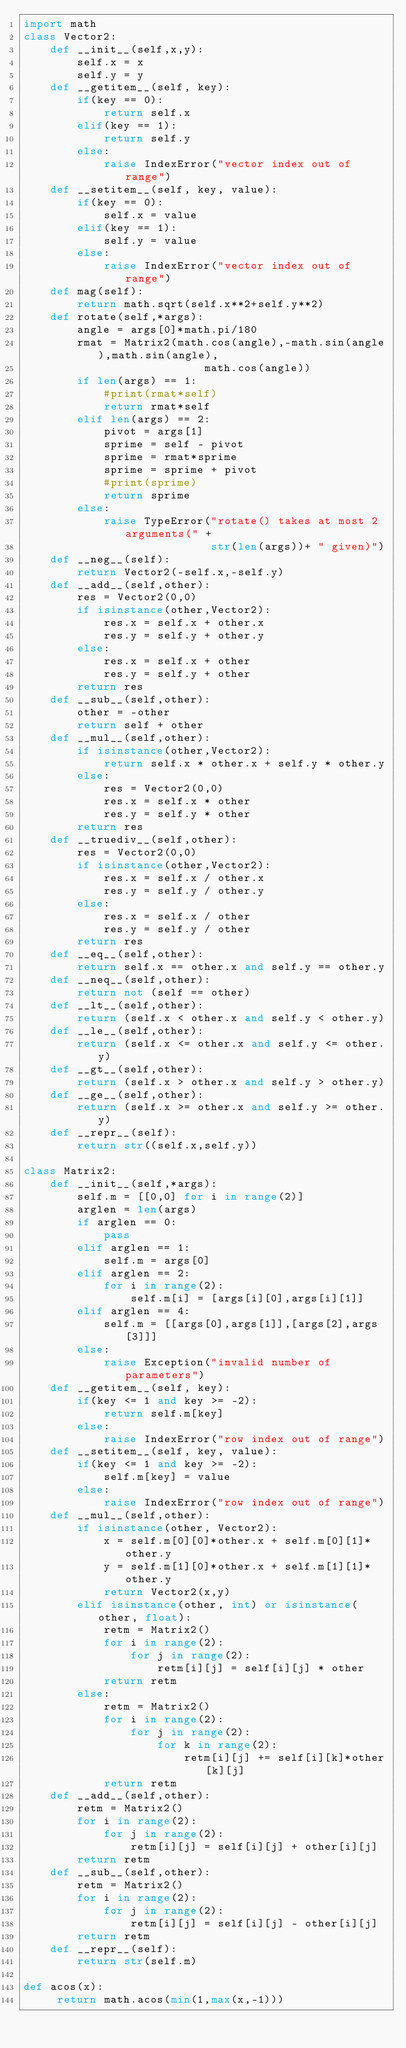Convert code to text. <code><loc_0><loc_0><loc_500><loc_500><_Python_>import math
class Vector2:
    def __init__(self,x,y):
        self.x = x
        self.y = y
    def __getitem__(self, key):
        if(key == 0):
            return self.x
        elif(key == 1):
            return self.y
        else:
            raise IndexError("vector index out of range")
    def __setitem__(self, key, value):
        if(key == 0):
            self.x = value
        elif(key == 1):
            self.y = value
        else:
            raise IndexError("vector index out of range")
    def mag(self):
        return math.sqrt(self.x**2+self.y**2)
    def rotate(self,*args):
        angle = args[0]*math.pi/180
        rmat = Matrix2(math.cos(angle),-math.sin(angle),math.sin(angle),
                           math.cos(angle))
        if len(args) == 1:
            #print(rmat*self)
            return rmat*self
        elif len(args) == 2:
            pivot = args[1]
            sprime = self - pivot
            sprime = rmat*sprime
            sprime = sprime + pivot
            #print(sprime)
            return sprime
        else:
            raise TypeError("rotate() takes at most 2 arguments(" +
                            str(len(args))+ " given)")
    def __neg__(self):
        return Vector2(-self.x,-self.y)
    def __add__(self,other):
        res = Vector2(0,0)
        if isinstance(other,Vector2):
            res.x = self.x + other.x
            res.y = self.y + other.y
        else:
            res.x = self.x + other
            res.y = self.y + other
        return res
    def __sub__(self,other):
        other = -other
        return self + other
    def __mul__(self,other):
        if isinstance(other,Vector2):
            return self.x * other.x + self.y * other.y
        else:
            res = Vector2(0,0)
            res.x = self.x * other
            res.y = self.y * other
        return res
    def __truediv__(self,other):
        res = Vector2(0,0)
        if isinstance(other,Vector2):
            res.x = self.x / other.x
            res.y = self.y / other.y
        else:
            res.x = self.x / other
            res.y = self.y / other
        return res
    def __eq__(self,other):
        return self.x == other.x and self.y == other.y
    def __neq__(self,other):
        return not (self == other)
    def __lt__(self,other):
        return (self.x < other.x and self.y < other.y)
    def __le__(self,other):
        return (self.x <= other.x and self.y <= other.y)
    def __gt__(self,other):
        return (self.x > other.x and self.y > other.y)
    def __ge__(self,other):
        return (self.x >= other.x and self.y >= other.y)
    def __repr__(self):
        return str((self.x,self.y))
    
class Matrix2:
    def __init__(self,*args):
        self.m = [[0,0] for i in range(2)]
        arglen = len(args)
        if arglen == 0:
            pass
        elif arglen == 1:
            self.m = args[0]
        elif arglen == 2:
            for i in range(2):
                self.m[i] = [args[i][0],args[i][1]]
        elif arglen == 4:
            self.m = [[args[0],args[1]],[args[2],args[3]]]
        else:
            raise Exception("invalid number of parameters")
    def __getitem__(self, key):
        if(key <= 1 and key >= -2):
            return self.m[key]
        else:
            raise IndexError("row index out of range")
    def __setitem__(self, key, value):
        if(key <= 1 and key >= -2):
            self.m[key] = value
        else:
            raise IndexError("row index out of range")
    def __mul__(self,other):
        if isinstance(other, Vector2):
            x = self.m[0][0]*other.x + self.m[0][1]*other.y
            y = self.m[1][0]*other.x + self.m[1][1]*other.y
            return Vector2(x,y)
        elif isinstance(other, int) or isinstance(other, float):
            retm = Matrix2()
            for i in range(2):
                for j in range(2):
                    retm[i][j] = self[i][j] * other
            return retm
        else:
            retm = Matrix2()
            for i in range(2):
                for j in range(2):
                    for k in range(2):
                        retm[i][j] += self[i][k]*other[k][j]
            return retm
    def __add__(self,other):
        retm = Matrix2()
        for i in range(2):
            for j in range(2):
                retm[i][j] = self[i][j] + other[i][j]
        return retm
    def __sub__(self,other):
        retm = Matrix2()
        for i in range(2):
            for j in range(2):
                retm[i][j] = self[i][j] - other[i][j]
        return retm
    def __repr__(self):
        return str(self.m)

def acos(x):
     return math.acos(min(1,max(x,-1)))
    
            
</code> 